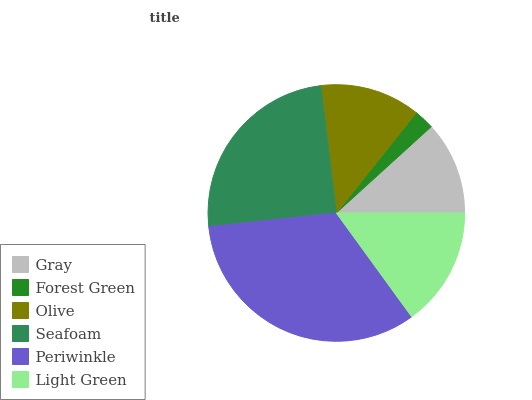Is Forest Green the minimum?
Answer yes or no. Yes. Is Periwinkle the maximum?
Answer yes or no. Yes. Is Olive the minimum?
Answer yes or no. No. Is Olive the maximum?
Answer yes or no. No. Is Olive greater than Forest Green?
Answer yes or no. Yes. Is Forest Green less than Olive?
Answer yes or no. Yes. Is Forest Green greater than Olive?
Answer yes or no. No. Is Olive less than Forest Green?
Answer yes or no. No. Is Light Green the high median?
Answer yes or no. Yes. Is Olive the low median?
Answer yes or no. Yes. Is Periwinkle the high median?
Answer yes or no. No. Is Light Green the low median?
Answer yes or no. No. 